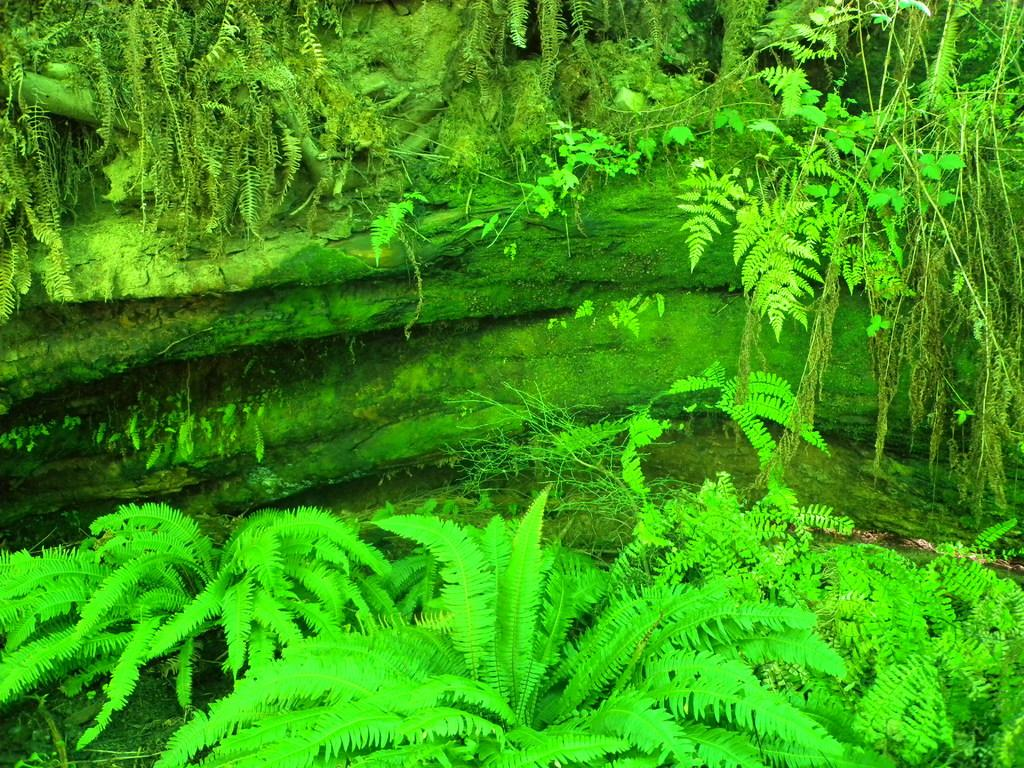What type of vegetation is present at the bottom of the image? There are trees at the bottom of the image. What natural element can be seen in the background of the image? There is water visible in the background of the image. Are there any other trees visible in the image? Yes, there are trees in the background of the image. What type of furniture is present in the image? There is no furniture present in the image. How does the water stretch across the background of the image? The water does not stretch across the background of the image; it is a static element in the background. 